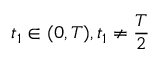<formula> <loc_0><loc_0><loc_500><loc_500>t _ { 1 } \in ( 0 , T ) , t _ { 1 } \neq \frac { T } { 2 }</formula> 